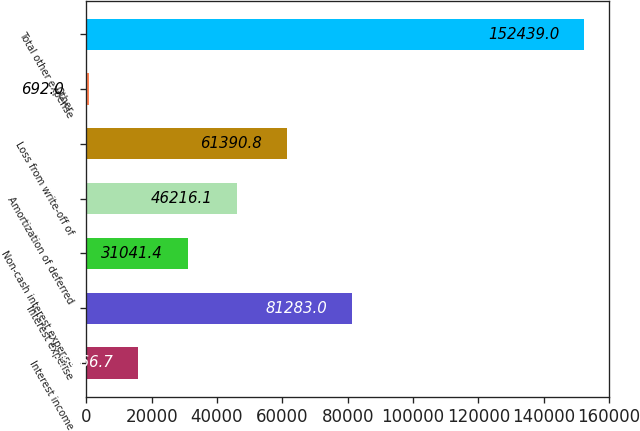Convert chart to OTSL. <chart><loc_0><loc_0><loc_500><loc_500><bar_chart><fcel>Interest income<fcel>Interest expense<fcel>Non-cash interest expense<fcel>Amortization of deferred<fcel>Loss from write-off of<fcel>Other<fcel>Total other expense<nl><fcel>15866.7<fcel>81283<fcel>31041.4<fcel>46216.1<fcel>61390.8<fcel>692<fcel>152439<nl></chart> 